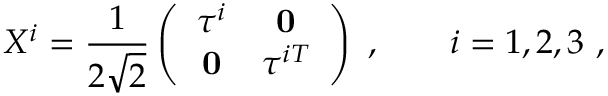<formula> <loc_0><loc_0><loc_500><loc_500>X ^ { i } = \frac { 1 } { 2 \sqrt { 2 } } \left ( \begin{array} { c c } { { \tau ^ { i } } } & { 0 } \\ { 0 } & { { \tau ^ { i T } } } \end{array} \right ) \ , \quad i = 1 , 2 , 3 \ ,</formula> 